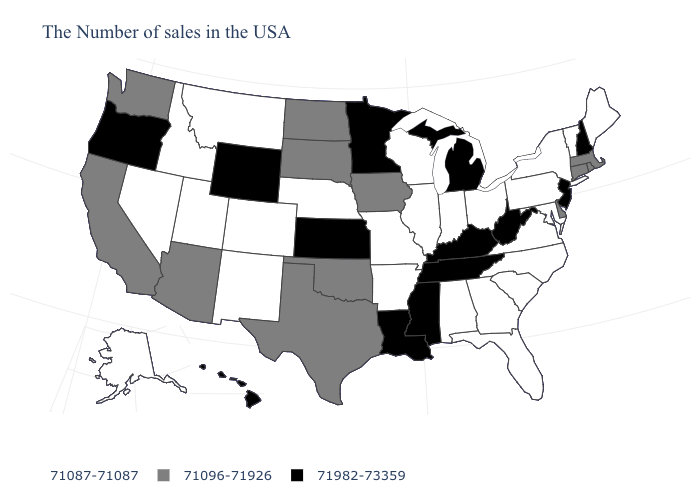How many symbols are there in the legend?
Keep it brief. 3. What is the value of Maryland?
Keep it brief. 71087-71087. Name the states that have a value in the range 71096-71926?
Keep it brief. Massachusetts, Rhode Island, Connecticut, Delaware, Iowa, Oklahoma, Texas, South Dakota, North Dakota, Arizona, California, Washington. What is the value of New Hampshire?
Answer briefly. 71982-73359. Among the states that border Nebraska , does Iowa have the lowest value?
Give a very brief answer. No. Among the states that border Tennessee , which have the lowest value?
Give a very brief answer. Virginia, North Carolina, Georgia, Alabama, Missouri, Arkansas. What is the lowest value in states that border Wisconsin?
Short answer required. 71087-71087. What is the highest value in the Northeast ?
Keep it brief. 71982-73359. Which states hav the highest value in the MidWest?
Short answer required. Michigan, Minnesota, Kansas. Name the states that have a value in the range 71096-71926?
Keep it brief. Massachusetts, Rhode Island, Connecticut, Delaware, Iowa, Oklahoma, Texas, South Dakota, North Dakota, Arizona, California, Washington. Is the legend a continuous bar?
Write a very short answer. No. Name the states that have a value in the range 71096-71926?
Give a very brief answer. Massachusetts, Rhode Island, Connecticut, Delaware, Iowa, Oklahoma, Texas, South Dakota, North Dakota, Arizona, California, Washington. What is the value of New Hampshire?
Write a very short answer. 71982-73359. What is the value of Washington?
Keep it brief. 71096-71926. What is the value of Wyoming?
Give a very brief answer. 71982-73359. 